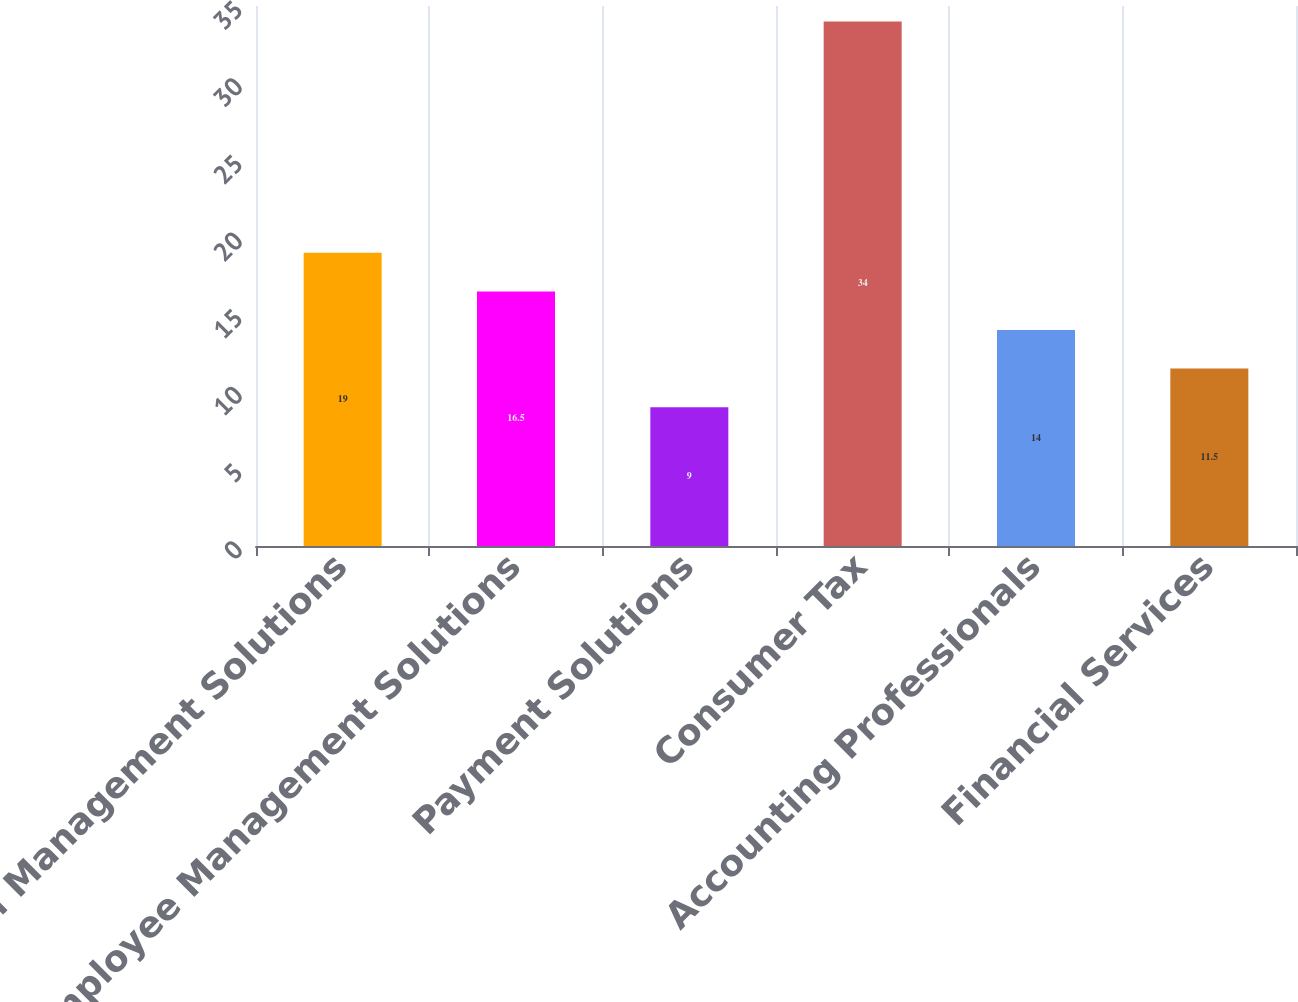<chart> <loc_0><loc_0><loc_500><loc_500><bar_chart><fcel>Financial Management Solutions<fcel>Employee Management Solutions<fcel>Payment Solutions<fcel>Consumer Tax<fcel>Accounting Professionals<fcel>Financial Services<nl><fcel>19<fcel>16.5<fcel>9<fcel>34<fcel>14<fcel>11.5<nl></chart> 